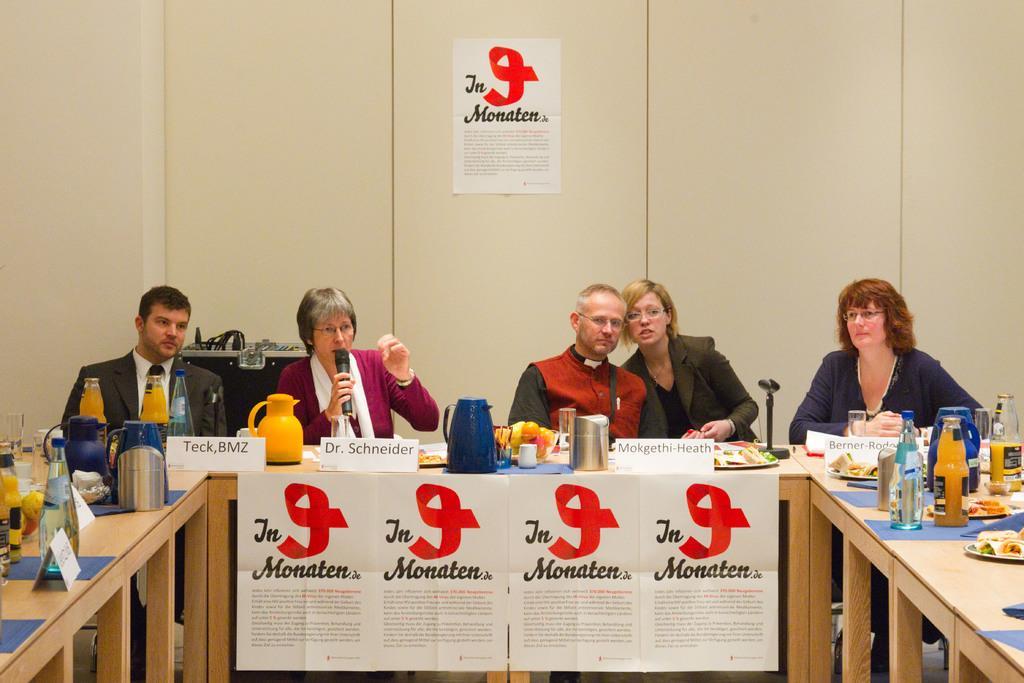Can you describe this image briefly? This picture shows few people seated on the chairs and we see a woman holding a microphone and speaking and we see few flasks glasses on the table 